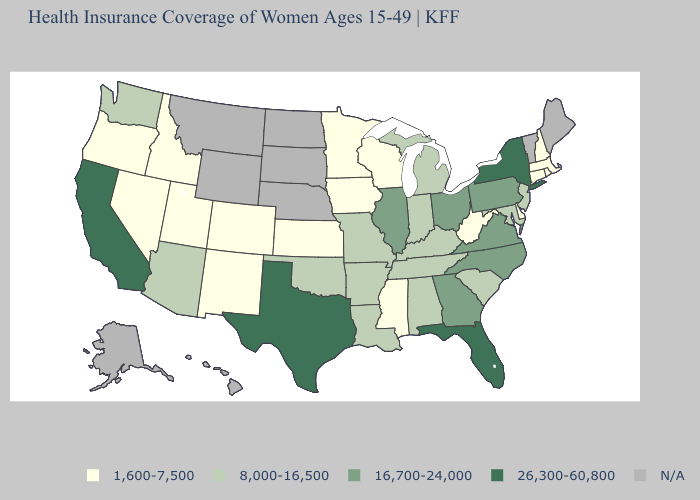Name the states that have a value in the range 26,300-60,800?
Be succinct. California, Florida, New York, Texas. What is the lowest value in the South?
Keep it brief. 1,600-7,500. How many symbols are there in the legend?
Quick response, please. 5. Name the states that have a value in the range 26,300-60,800?
Be succinct. California, Florida, New York, Texas. What is the value of New Jersey?
Short answer required. 8,000-16,500. Does the map have missing data?
Short answer required. Yes. Name the states that have a value in the range N/A?
Give a very brief answer. Alaska, Hawaii, Maine, Montana, Nebraska, North Dakota, South Dakota, Vermont, Wyoming. How many symbols are there in the legend?
Quick response, please. 5. What is the highest value in states that border Washington?
Write a very short answer. 1,600-7,500. What is the value of Oregon?
Answer briefly. 1,600-7,500. Which states have the lowest value in the USA?
Quick response, please. Colorado, Connecticut, Delaware, Idaho, Iowa, Kansas, Massachusetts, Minnesota, Mississippi, Nevada, New Hampshire, New Mexico, Oregon, Rhode Island, Utah, West Virginia, Wisconsin. Among the states that border Virginia , which have the highest value?
Short answer required. North Carolina. Name the states that have a value in the range 26,300-60,800?
Concise answer only. California, Florida, New York, Texas. Does the first symbol in the legend represent the smallest category?
Give a very brief answer. Yes. 